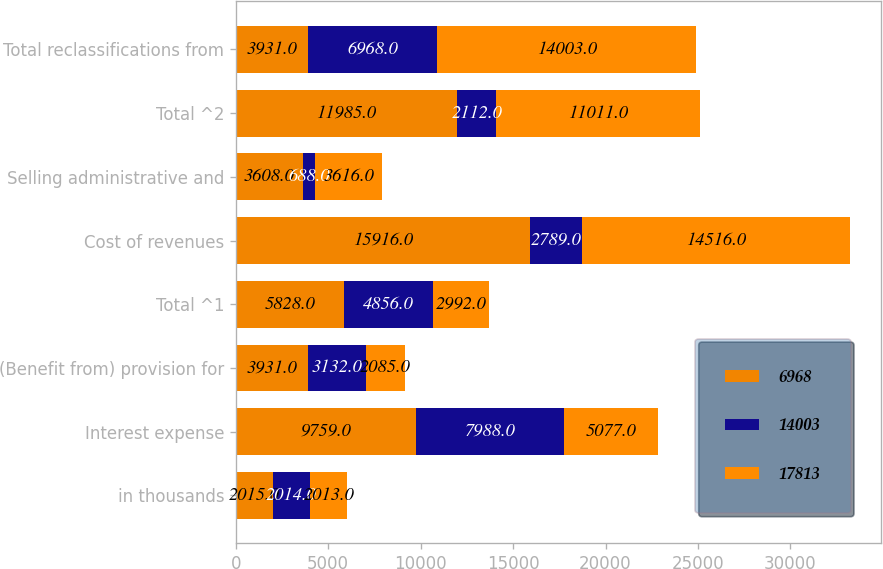Convert chart to OTSL. <chart><loc_0><loc_0><loc_500><loc_500><stacked_bar_chart><ecel><fcel>in thousands<fcel>Interest expense<fcel>(Benefit from) provision for<fcel>Total ^1<fcel>Cost of revenues<fcel>Selling administrative and<fcel>Total ^2<fcel>Total reclassifications from<nl><fcel>6968<fcel>2015<fcel>9759<fcel>3931<fcel>5828<fcel>15916<fcel>3608<fcel>11985<fcel>3931<nl><fcel>14003<fcel>2014<fcel>7988<fcel>3132<fcel>4856<fcel>2789<fcel>688<fcel>2112<fcel>6968<nl><fcel>17813<fcel>2013<fcel>5077<fcel>2085<fcel>2992<fcel>14516<fcel>3616<fcel>11011<fcel>14003<nl></chart> 